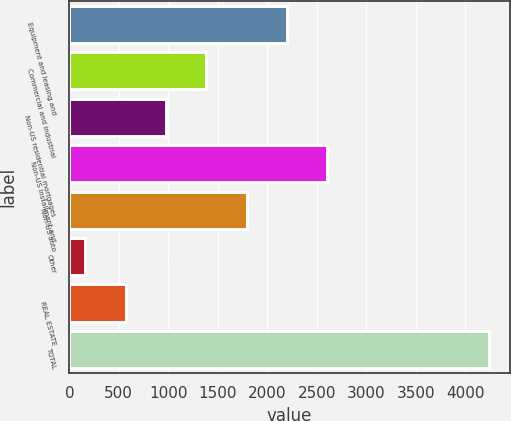Convert chart. <chart><loc_0><loc_0><loc_500><loc_500><bar_chart><fcel>Equipment and leasing and<fcel>Commercial and industrial<fcel>Non-US residential mortgages<fcel>Non-US installment and<fcel>Non-US auto<fcel>Other<fcel>REAL ESTATE<fcel>TOTAL<nl><fcel>2200<fcel>1384.8<fcel>977.2<fcel>2607.6<fcel>1792.4<fcel>162<fcel>569.6<fcel>4238<nl></chart> 